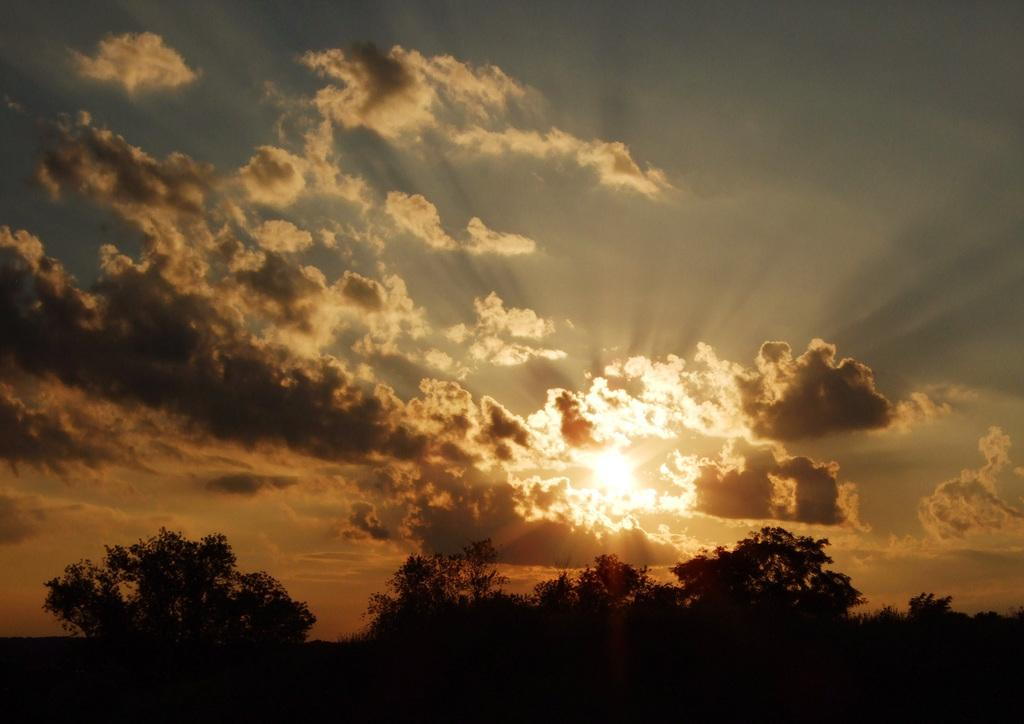What can be seen in the image? There are many trees in the image. What is happening in the sky? There is a sunset visible in the sky. What type of pear is the fireman holding in the image? There is no fireman or pear present in the image; it only features trees and a sunset. 